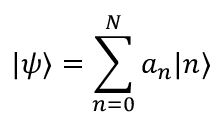Convert formula to latex. <formula><loc_0><loc_0><loc_500><loc_500>| \psi \rangle = \sum _ { n = 0 } ^ { N } a _ { n } | n \rangle</formula> 